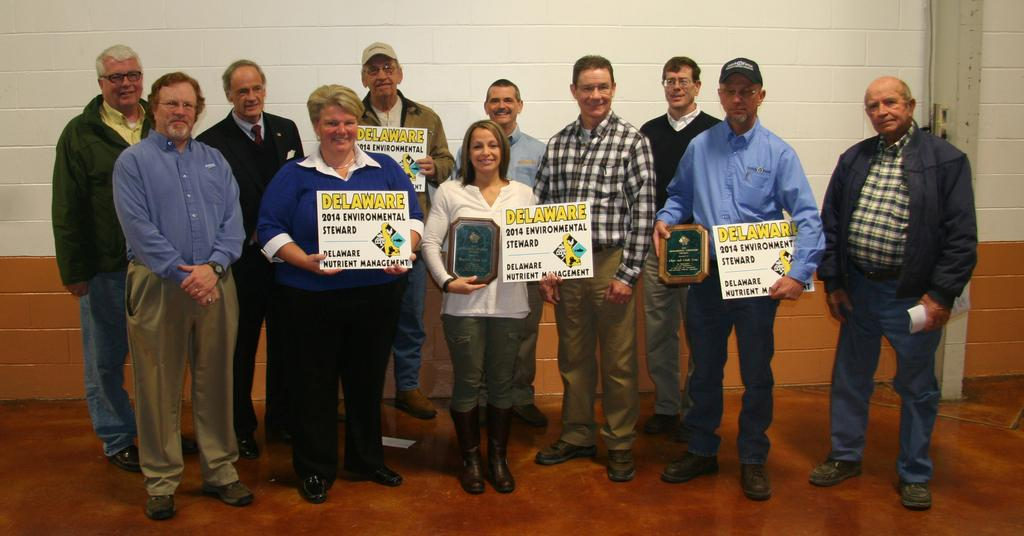What are the people in the center of the picture doing? The people in the center of the picture are standing and holding placards. What else are the people holding in the image? The people are also holding memorandums. What can be seen in the background of the image? There is a well in the background of the image. What type of structure is being pulled by the people in the image? There is no structure being pulled by the people in the image; they are holding placards and memorandums. Can you describe the cushion that is present in the image? There is no cushion present in the image. 